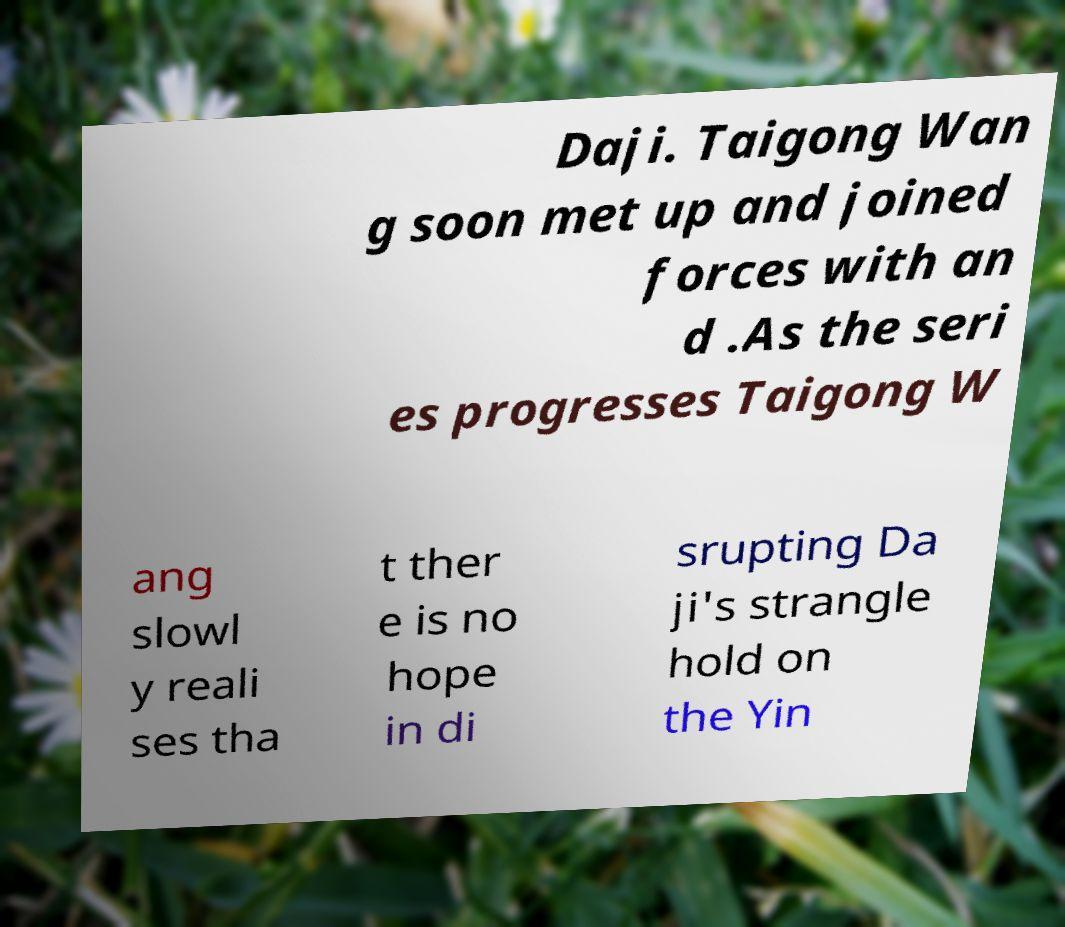What messages or text are displayed in this image? I need them in a readable, typed format. Daji. Taigong Wan g soon met up and joined forces with an d .As the seri es progresses Taigong W ang slowl y reali ses tha t ther e is no hope in di srupting Da ji's strangle hold on the Yin 